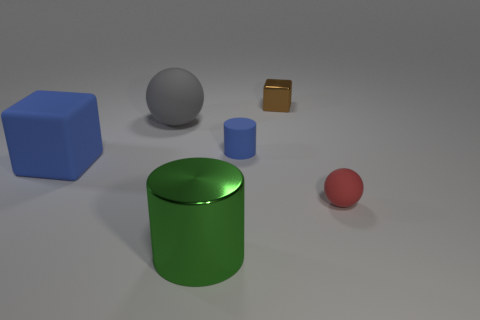Does the large ball have the same material as the big green object?
Offer a terse response. No. What color is the thing that is on the left side of the green thing and right of the large blue block?
Keep it short and to the point. Gray. Does the sphere behind the big blue matte cube have the same color as the small cylinder?
Offer a terse response. No. There is a rubber thing that is the same size as the gray sphere; what shape is it?
Provide a succinct answer. Cube. How many other things are the same color as the big cube?
Offer a terse response. 1. What number of other objects are the same material as the blue block?
Offer a very short reply. 3. Do the gray matte thing and the rubber ball right of the tiny brown metallic cube have the same size?
Your answer should be very brief. No. What color is the rubber cube?
Give a very brief answer. Blue. The small matte thing that is behind the blue rubber thing that is on the left side of the sphere that is left of the blue cylinder is what shape?
Offer a very short reply. Cylinder. What material is the sphere in front of the blue rubber object that is left of the tiny blue rubber cylinder made of?
Make the answer very short. Rubber. 